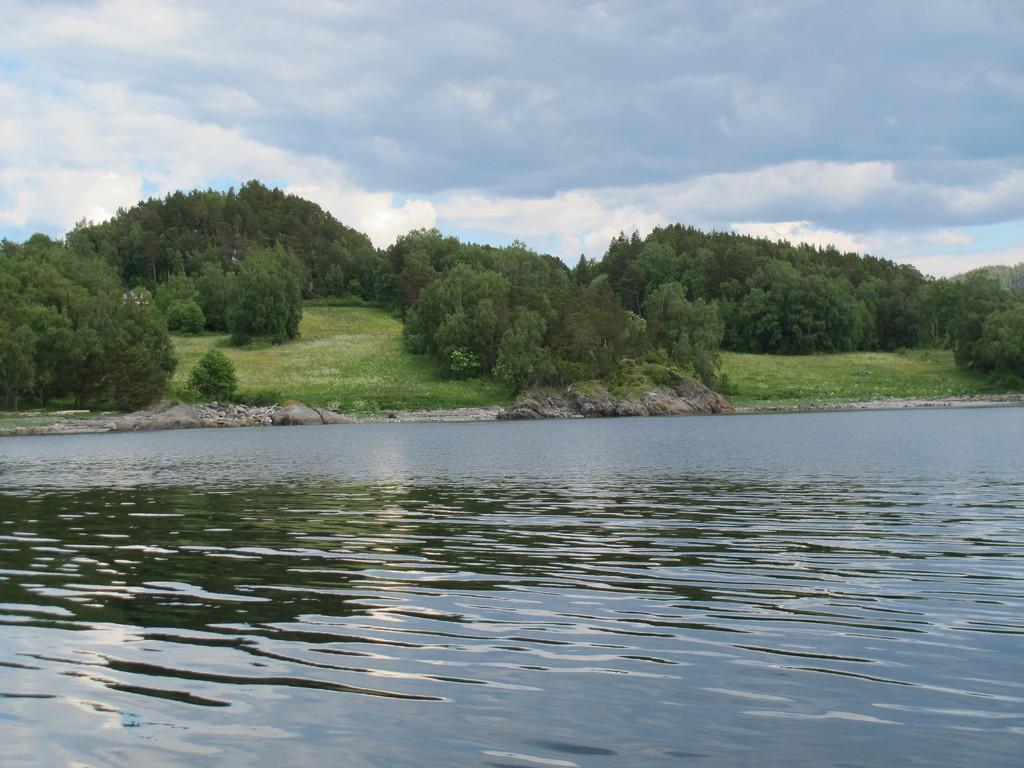In one or two sentences, can you explain what this image depicts? In this image we can see water. In the back there are rocks and trees. On the ground there is grass. In the back there is sky with clouds. 